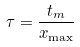<formula> <loc_0><loc_0><loc_500><loc_500>\tau = \frac { t _ { m } } { x _ { \max } }</formula> 